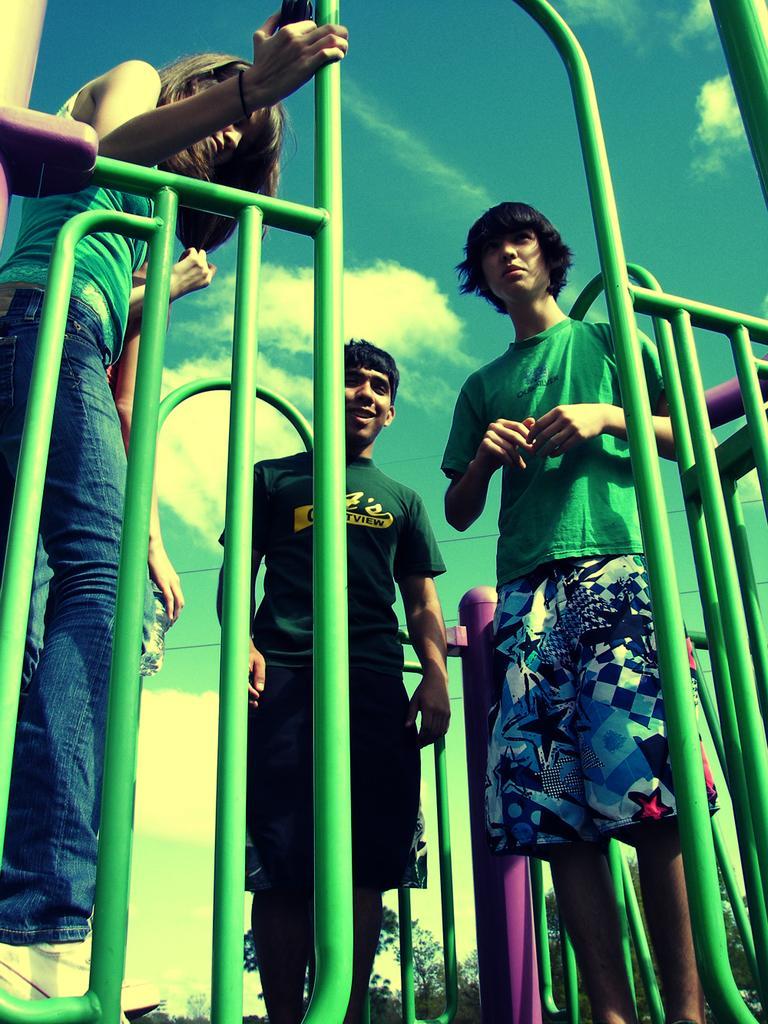Can you describe this image briefly? In this image we can see few persons are standing at the railings and among them a woman is holding the railing and another person is holding water bottle in the hand. In the background we can see trees and clouds in the sky. 